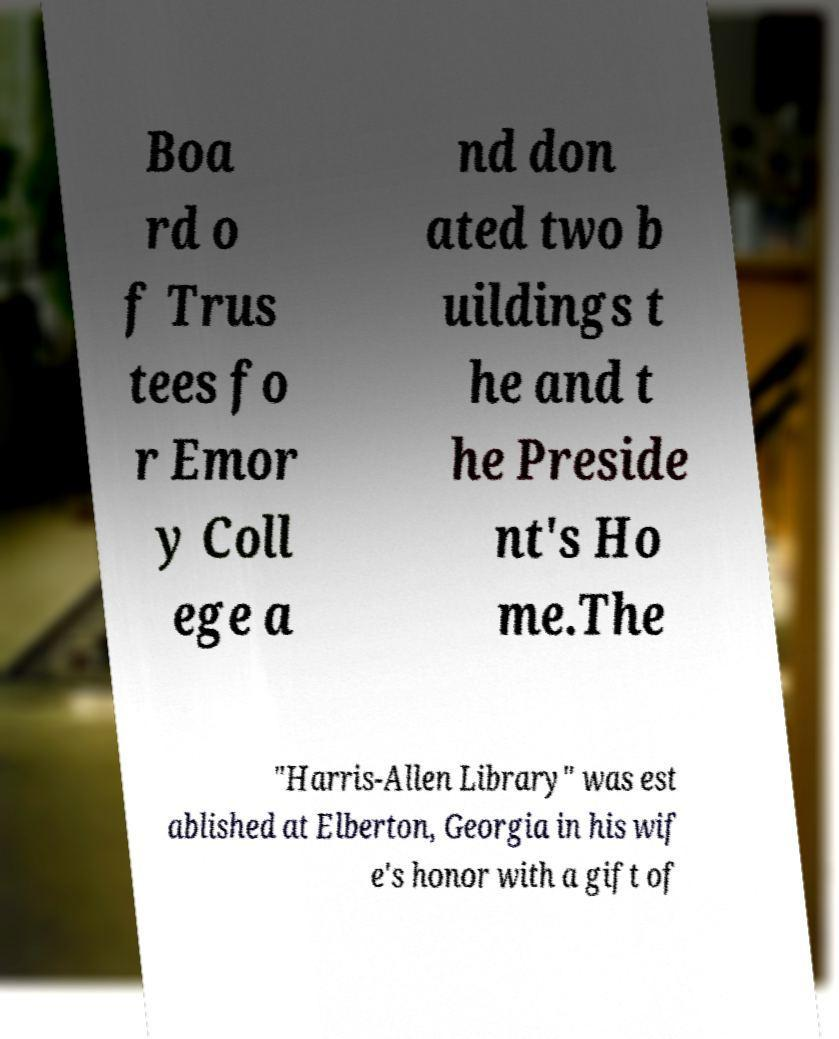Could you extract and type out the text from this image? Boa rd o f Trus tees fo r Emor y Coll ege a nd don ated two b uildings t he and t he Preside nt's Ho me.The "Harris-Allen Library" was est ablished at Elberton, Georgia in his wif e's honor with a gift of 